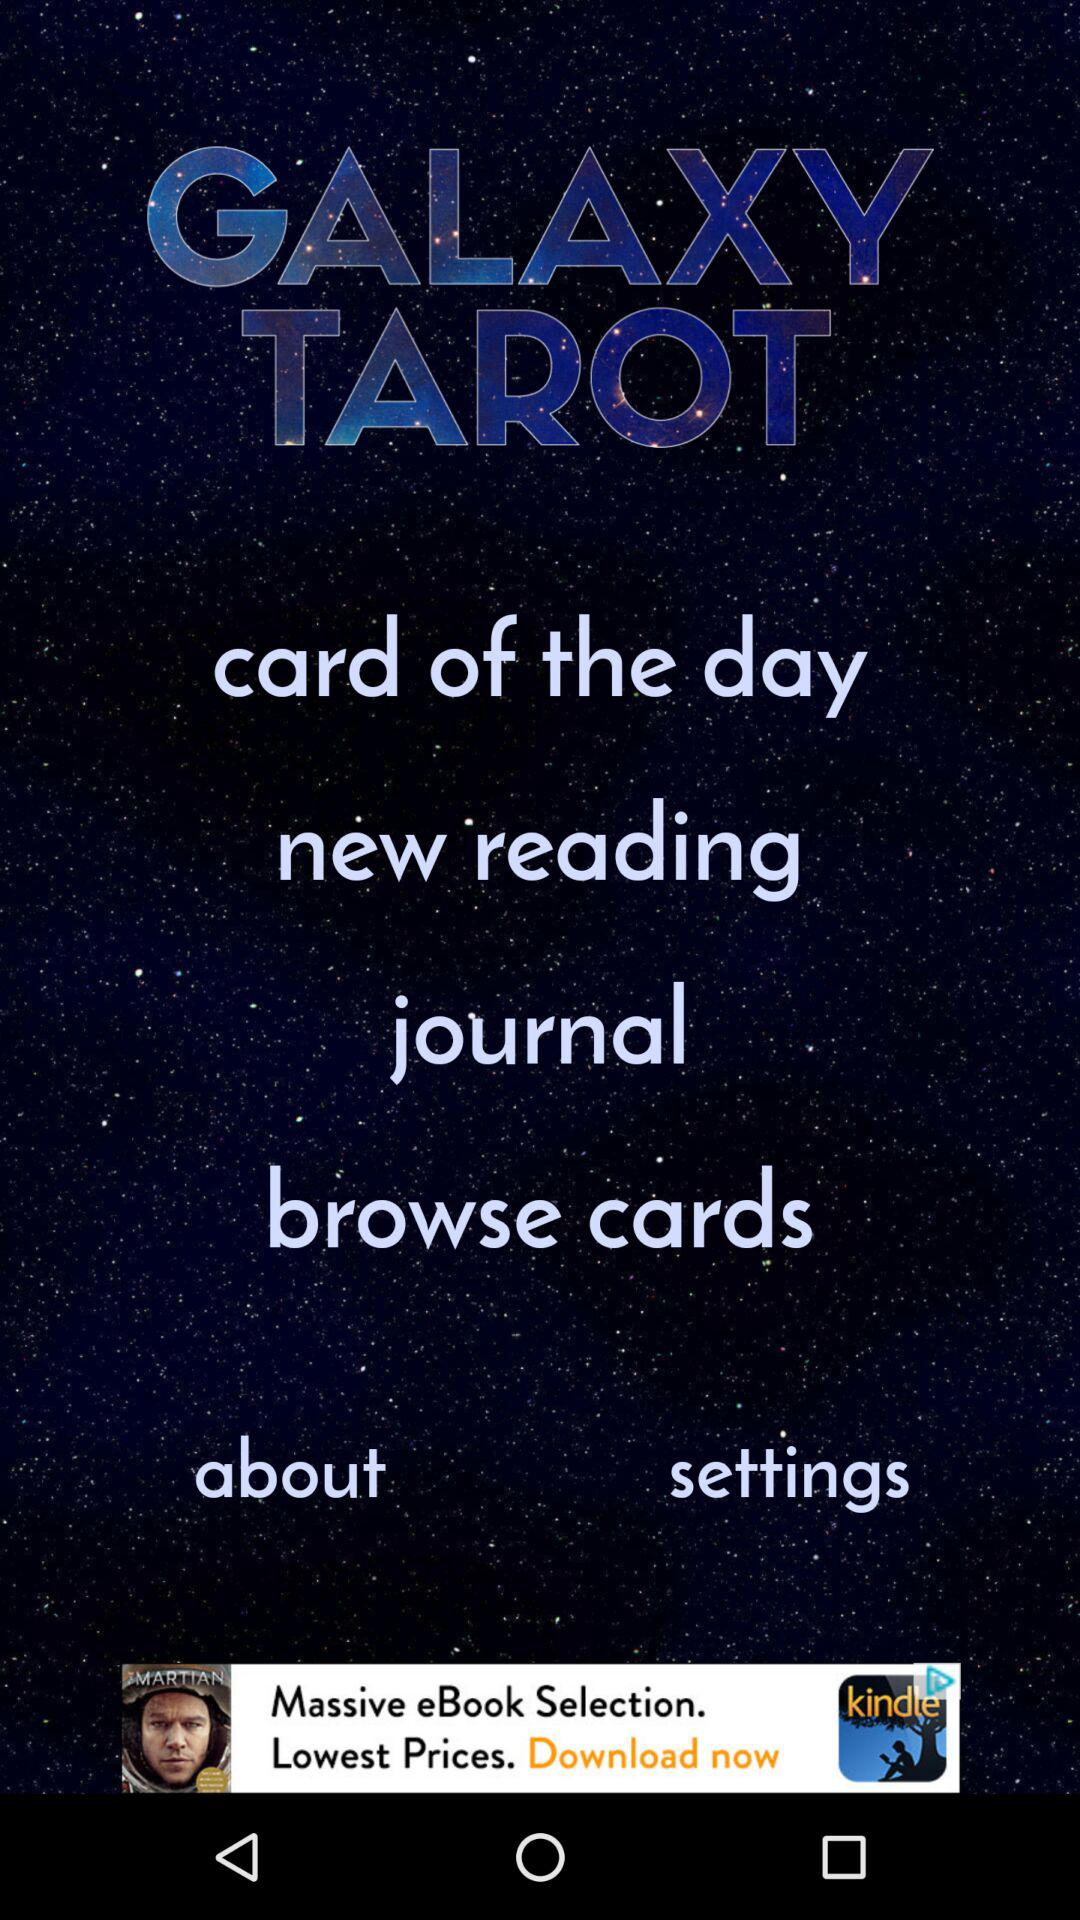What is the application name? The application name is "GALAXY TAROT". 